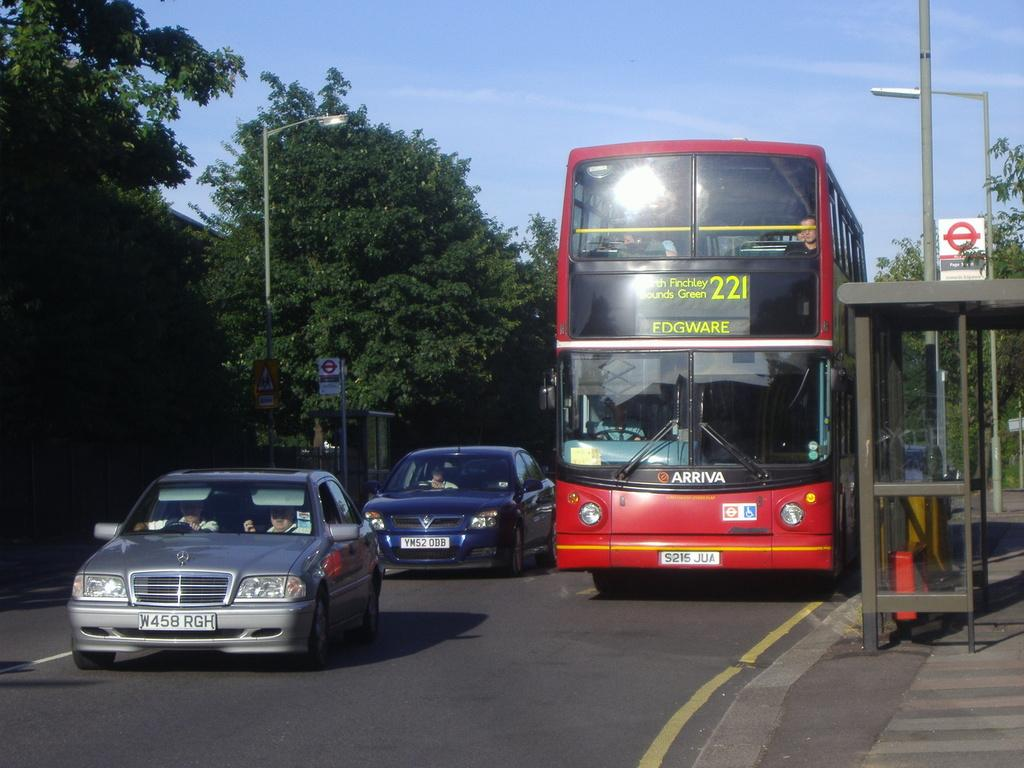What is happening on the road in the image? There are vehicles on the road in the image, and people are inside them. What can be seen on the right side of the image? There is a shed on the right side of the image. What is present on the poles in the background? Lights and boards are present on poles in the background. What type of vegetation is visible in the background? Trees are visible in the background. What is visible in the sky in the background? The sky is visible in the background. Where is the cow grazing in the image? There is no cow present in the image. What type of sticks are being used by the people in the vehicles? There is no mention of sticks in the image. 